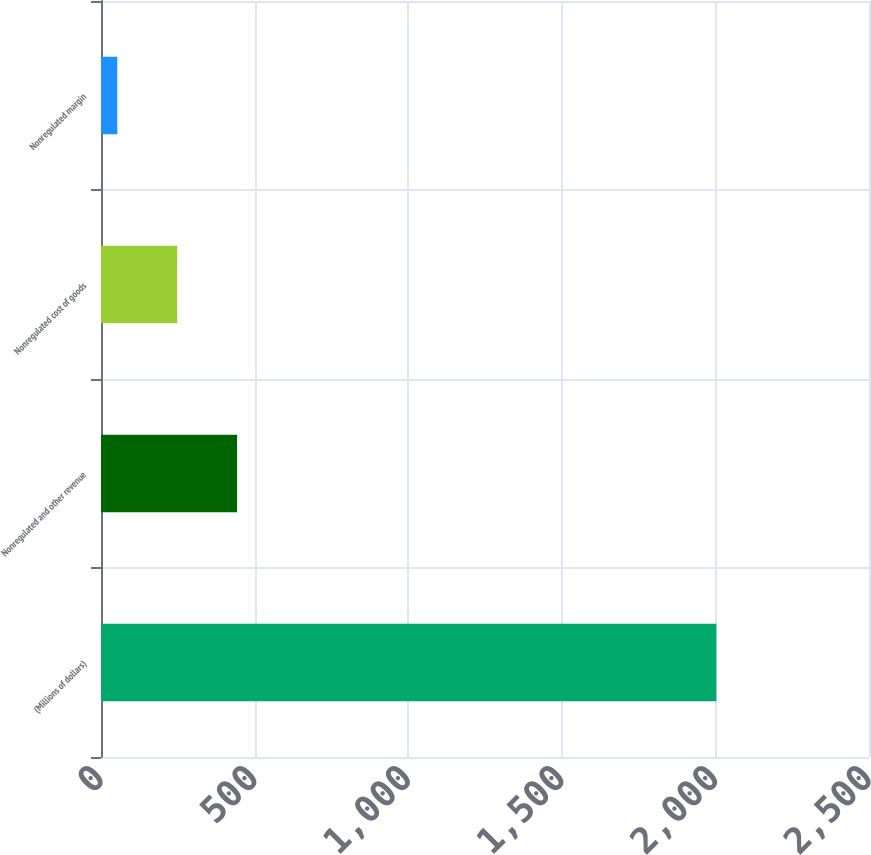Convert chart. <chart><loc_0><loc_0><loc_500><loc_500><bar_chart><fcel>(Millions of dollars)<fcel>Nonregulated and other revenue<fcel>Nonregulated cost of goods<fcel>Nonregulated margin<nl><fcel>2003<fcel>443<fcel>248<fcel>53<nl></chart> 